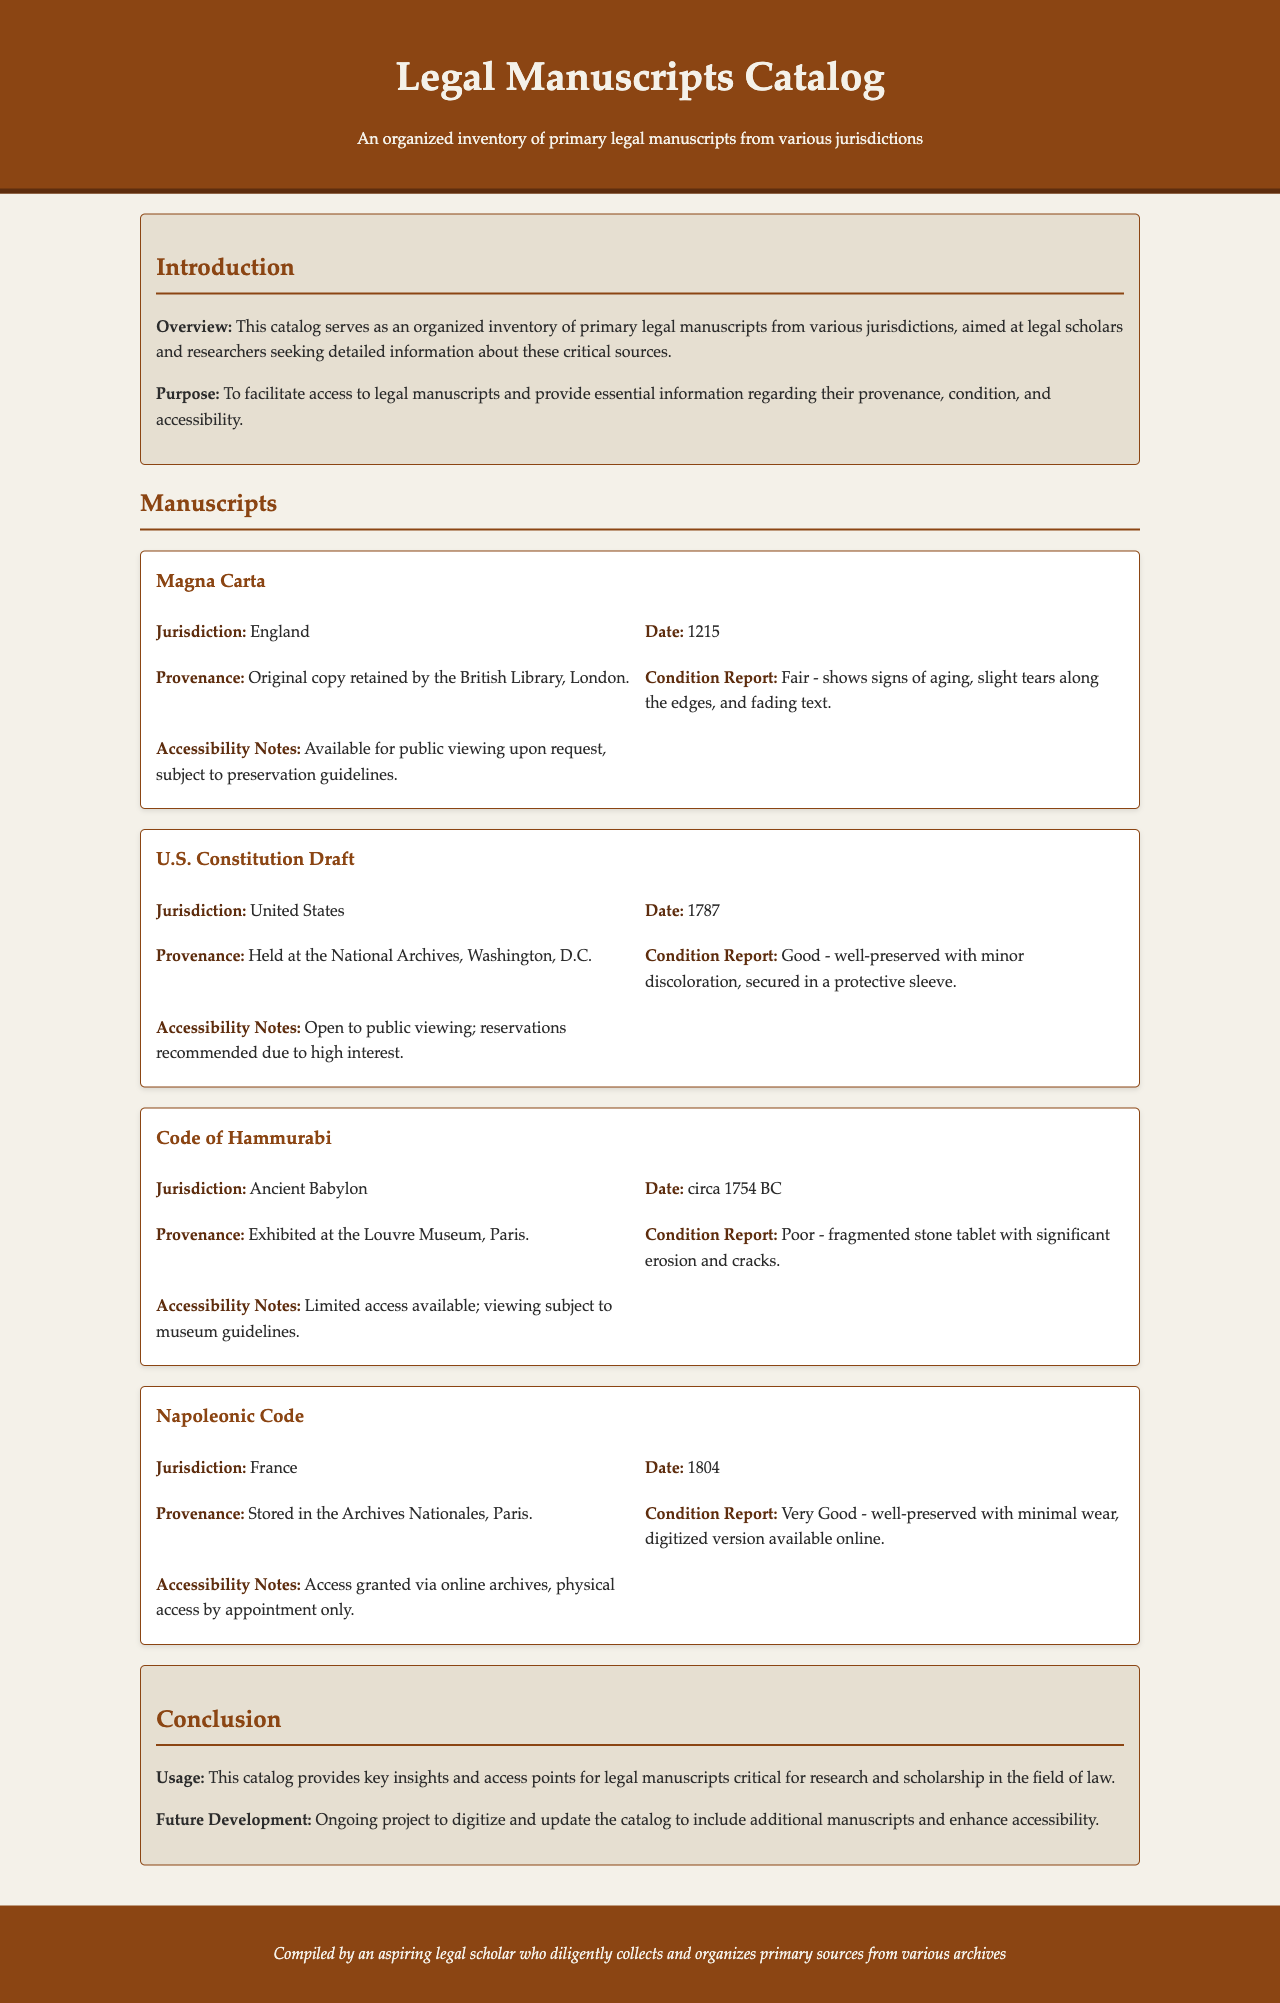What is the title of the catalog? The title is prominently displayed in the header section of the document.
Answer: Legal Manuscripts Catalog Who holds the Magna Carta? The document mentions the provenance of the Magna Carta.
Answer: British Library, London What is the condition of the Code of Hammurabi? The condition report provides details about the state of the manuscript.
Answer: Poor What year was the Napoleonic Code established? The date is explicitly stated in the manuscript details.
Answer: 1804 How many manuscripts are mentioned in the document? The number of manuscripts can be counted in the manuscripts section.
Answer: Four What is the accessibility note for the U.S. Constitution Draft? The document provides specific guidelines for accessing this manuscript.
Answer: Open to public viewing; reservations recommended Which jurisdiction is associated with the Code of Hammurabi? The jurisdiction is noted in the manuscript information.
Answer: Ancient Babylon What preservation status does the Napoleonic Code have? The condition report describes the preservation status of the manuscript.
Answer: Very Good What is the purpose of this catalog? The purpose is summarized in the introduction section of the document.
Answer: To facilitate access to legal manuscripts 